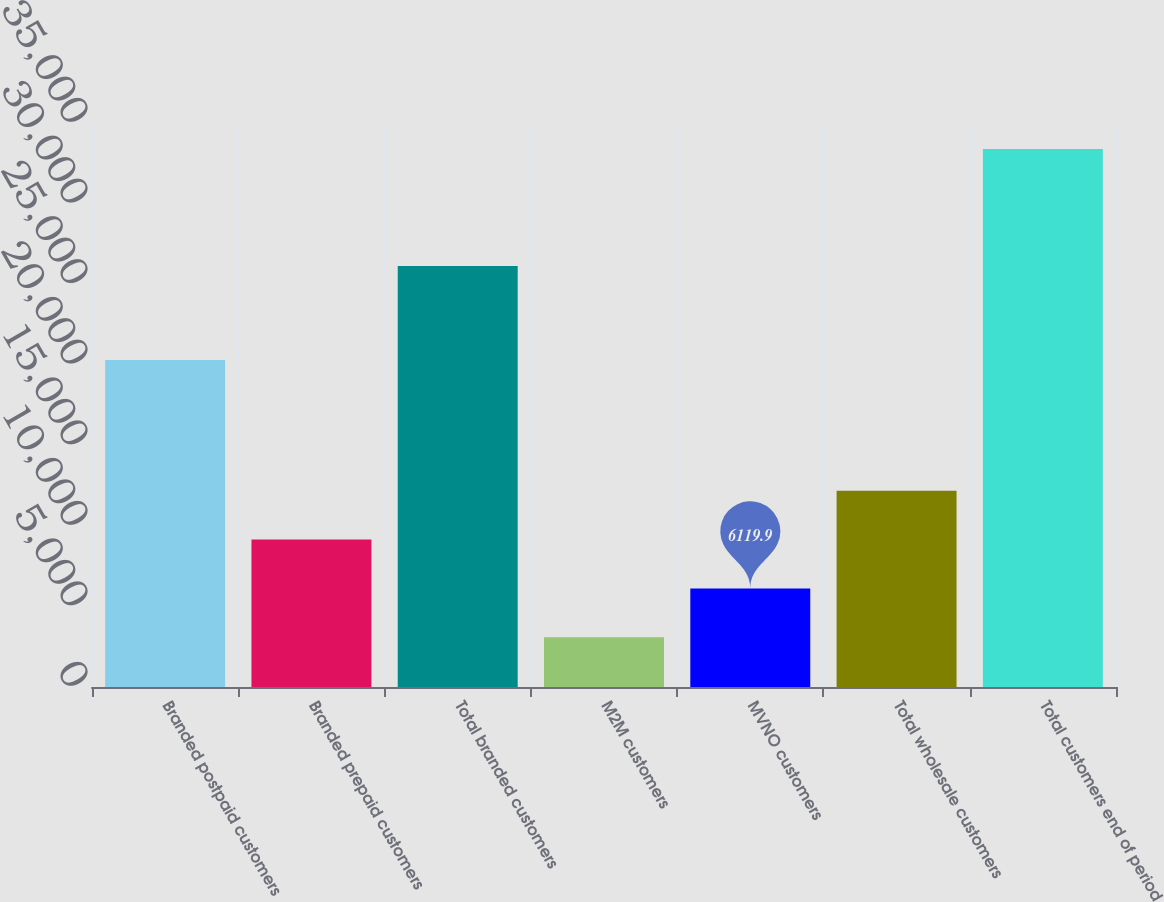Convert chart to OTSL. <chart><loc_0><loc_0><loc_500><loc_500><bar_chart><fcel>Branded postpaid customers<fcel>Branded prepaid customers<fcel>Total branded customers<fcel>M2M customers<fcel>MVNO customers<fcel>Total wholesale customers<fcel>Total customers end of period<nl><fcel>20293<fcel>9149.8<fcel>26119<fcel>3090<fcel>6119.9<fcel>12179.7<fcel>33389<nl></chart> 